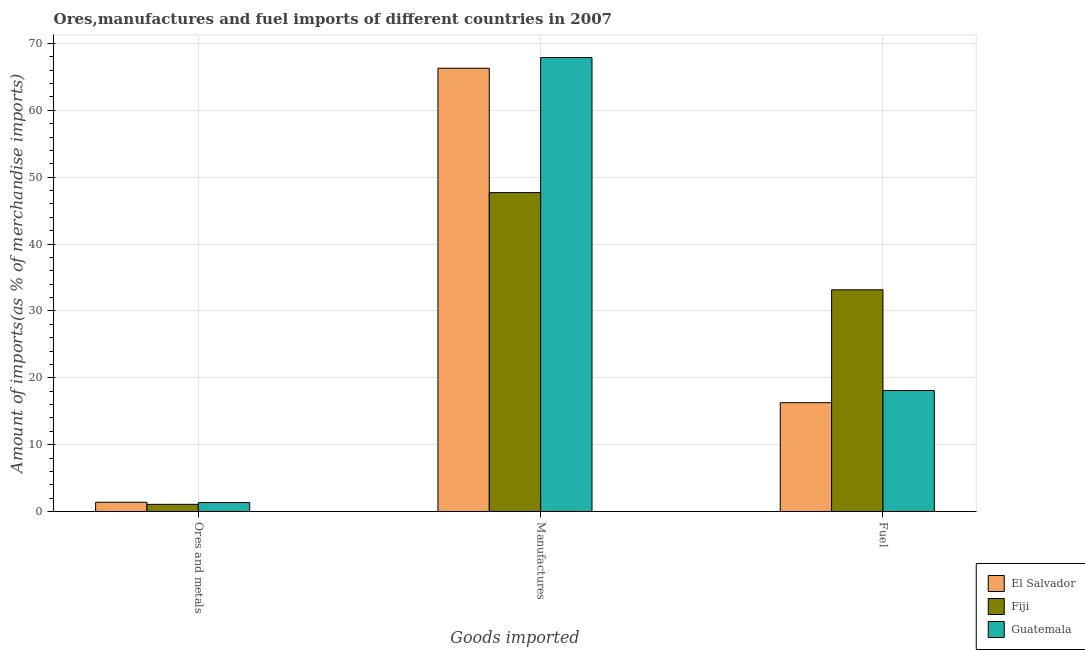How many different coloured bars are there?
Your answer should be very brief. 3. Are the number of bars per tick equal to the number of legend labels?
Your response must be concise. Yes. How many bars are there on the 1st tick from the right?
Ensure brevity in your answer.  3. What is the label of the 2nd group of bars from the left?
Keep it short and to the point. Manufactures. What is the percentage of ores and metals imports in El Salvador?
Give a very brief answer. 1.38. Across all countries, what is the maximum percentage of ores and metals imports?
Offer a very short reply. 1.38. Across all countries, what is the minimum percentage of fuel imports?
Provide a short and direct response. 16.27. In which country was the percentage of manufactures imports maximum?
Make the answer very short. Guatemala. In which country was the percentage of manufactures imports minimum?
Your response must be concise. Fiji. What is the total percentage of manufactures imports in the graph?
Your response must be concise. 181.9. What is the difference between the percentage of manufactures imports in Guatemala and that in Fiji?
Keep it short and to the point. 20.2. What is the difference between the percentage of manufactures imports in El Salvador and the percentage of ores and metals imports in Guatemala?
Provide a short and direct response. 64.96. What is the average percentage of manufactures imports per country?
Keep it short and to the point. 60.63. What is the difference between the percentage of ores and metals imports and percentage of manufactures imports in El Salvador?
Give a very brief answer. -64.92. In how many countries, is the percentage of ores and metals imports greater than 58 %?
Your answer should be compact. 0. What is the ratio of the percentage of fuel imports in Fiji to that in Guatemala?
Offer a terse response. 1.83. What is the difference between the highest and the second highest percentage of fuel imports?
Your answer should be compact. 15.07. What is the difference between the highest and the lowest percentage of fuel imports?
Your answer should be very brief. 16.89. Is the sum of the percentage of fuel imports in Fiji and El Salvador greater than the maximum percentage of ores and metals imports across all countries?
Give a very brief answer. Yes. What does the 2nd bar from the left in Fuel represents?
Give a very brief answer. Fiji. What does the 2nd bar from the right in Ores and metals represents?
Provide a short and direct response. Fiji. How many bars are there?
Your answer should be very brief. 9. Are all the bars in the graph horizontal?
Your response must be concise. No. What is the difference between two consecutive major ticks on the Y-axis?
Provide a succinct answer. 10. Does the graph contain grids?
Keep it short and to the point. Yes. Where does the legend appear in the graph?
Your response must be concise. Bottom right. How many legend labels are there?
Offer a very short reply. 3. What is the title of the graph?
Keep it short and to the point. Ores,manufactures and fuel imports of different countries in 2007. Does "Macao" appear as one of the legend labels in the graph?
Give a very brief answer. No. What is the label or title of the X-axis?
Provide a short and direct response. Goods imported. What is the label or title of the Y-axis?
Ensure brevity in your answer.  Amount of imports(as % of merchandise imports). What is the Amount of imports(as % of merchandise imports) of El Salvador in Ores and metals?
Ensure brevity in your answer.  1.38. What is the Amount of imports(as % of merchandise imports) in Fiji in Ores and metals?
Make the answer very short. 1.07. What is the Amount of imports(as % of merchandise imports) of Guatemala in Ores and metals?
Provide a succinct answer. 1.34. What is the Amount of imports(as % of merchandise imports) of El Salvador in Manufactures?
Give a very brief answer. 66.3. What is the Amount of imports(as % of merchandise imports) in Fiji in Manufactures?
Provide a short and direct response. 47.7. What is the Amount of imports(as % of merchandise imports) of Guatemala in Manufactures?
Your answer should be very brief. 67.9. What is the Amount of imports(as % of merchandise imports) of El Salvador in Fuel?
Your answer should be compact. 16.27. What is the Amount of imports(as % of merchandise imports) of Fiji in Fuel?
Your response must be concise. 33.16. What is the Amount of imports(as % of merchandise imports) of Guatemala in Fuel?
Your answer should be very brief. 18.09. Across all Goods imported, what is the maximum Amount of imports(as % of merchandise imports) of El Salvador?
Your answer should be compact. 66.3. Across all Goods imported, what is the maximum Amount of imports(as % of merchandise imports) in Fiji?
Provide a succinct answer. 47.7. Across all Goods imported, what is the maximum Amount of imports(as % of merchandise imports) of Guatemala?
Provide a short and direct response. 67.9. Across all Goods imported, what is the minimum Amount of imports(as % of merchandise imports) in El Salvador?
Provide a succinct answer. 1.38. Across all Goods imported, what is the minimum Amount of imports(as % of merchandise imports) of Fiji?
Give a very brief answer. 1.07. Across all Goods imported, what is the minimum Amount of imports(as % of merchandise imports) in Guatemala?
Your answer should be compact. 1.34. What is the total Amount of imports(as % of merchandise imports) in El Salvador in the graph?
Your answer should be compact. 83.95. What is the total Amount of imports(as % of merchandise imports) of Fiji in the graph?
Your answer should be very brief. 81.93. What is the total Amount of imports(as % of merchandise imports) in Guatemala in the graph?
Keep it short and to the point. 87.33. What is the difference between the Amount of imports(as % of merchandise imports) in El Salvador in Ores and metals and that in Manufactures?
Give a very brief answer. -64.92. What is the difference between the Amount of imports(as % of merchandise imports) of Fiji in Ores and metals and that in Manufactures?
Offer a very short reply. -46.63. What is the difference between the Amount of imports(as % of merchandise imports) of Guatemala in Ores and metals and that in Manufactures?
Provide a short and direct response. -66.56. What is the difference between the Amount of imports(as % of merchandise imports) in El Salvador in Ores and metals and that in Fuel?
Make the answer very short. -14.89. What is the difference between the Amount of imports(as % of merchandise imports) in Fiji in Ores and metals and that in Fuel?
Offer a terse response. -32.09. What is the difference between the Amount of imports(as % of merchandise imports) in Guatemala in Ores and metals and that in Fuel?
Give a very brief answer. -16.76. What is the difference between the Amount of imports(as % of merchandise imports) in El Salvador in Manufactures and that in Fuel?
Provide a succinct answer. 50.03. What is the difference between the Amount of imports(as % of merchandise imports) of Fiji in Manufactures and that in Fuel?
Provide a short and direct response. 14.54. What is the difference between the Amount of imports(as % of merchandise imports) in Guatemala in Manufactures and that in Fuel?
Provide a succinct answer. 49.8. What is the difference between the Amount of imports(as % of merchandise imports) of El Salvador in Ores and metals and the Amount of imports(as % of merchandise imports) of Fiji in Manufactures?
Provide a succinct answer. -46.32. What is the difference between the Amount of imports(as % of merchandise imports) of El Salvador in Ores and metals and the Amount of imports(as % of merchandise imports) of Guatemala in Manufactures?
Ensure brevity in your answer.  -66.52. What is the difference between the Amount of imports(as % of merchandise imports) of Fiji in Ores and metals and the Amount of imports(as % of merchandise imports) of Guatemala in Manufactures?
Offer a very short reply. -66.83. What is the difference between the Amount of imports(as % of merchandise imports) of El Salvador in Ores and metals and the Amount of imports(as % of merchandise imports) of Fiji in Fuel?
Your answer should be very brief. -31.78. What is the difference between the Amount of imports(as % of merchandise imports) in El Salvador in Ores and metals and the Amount of imports(as % of merchandise imports) in Guatemala in Fuel?
Keep it short and to the point. -16.71. What is the difference between the Amount of imports(as % of merchandise imports) in Fiji in Ores and metals and the Amount of imports(as % of merchandise imports) in Guatemala in Fuel?
Ensure brevity in your answer.  -17.03. What is the difference between the Amount of imports(as % of merchandise imports) in El Salvador in Manufactures and the Amount of imports(as % of merchandise imports) in Fiji in Fuel?
Your answer should be compact. 33.14. What is the difference between the Amount of imports(as % of merchandise imports) in El Salvador in Manufactures and the Amount of imports(as % of merchandise imports) in Guatemala in Fuel?
Give a very brief answer. 48.21. What is the difference between the Amount of imports(as % of merchandise imports) of Fiji in Manufactures and the Amount of imports(as % of merchandise imports) of Guatemala in Fuel?
Offer a terse response. 29.61. What is the average Amount of imports(as % of merchandise imports) in El Salvador per Goods imported?
Provide a short and direct response. 27.98. What is the average Amount of imports(as % of merchandise imports) of Fiji per Goods imported?
Your answer should be very brief. 27.31. What is the average Amount of imports(as % of merchandise imports) of Guatemala per Goods imported?
Offer a very short reply. 29.11. What is the difference between the Amount of imports(as % of merchandise imports) in El Salvador and Amount of imports(as % of merchandise imports) in Fiji in Ores and metals?
Provide a short and direct response. 0.31. What is the difference between the Amount of imports(as % of merchandise imports) in El Salvador and Amount of imports(as % of merchandise imports) in Guatemala in Ores and metals?
Your answer should be compact. 0.05. What is the difference between the Amount of imports(as % of merchandise imports) in Fiji and Amount of imports(as % of merchandise imports) in Guatemala in Ores and metals?
Make the answer very short. -0.27. What is the difference between the Amount of imports(as % of merchandise imports) in El Salvador and Amount of imports(as % of merchandise imports) in Fiji in Manufactures?
Give a very brief answer. 18.6. What is the difference between the Amount of imports(as % of merchandise imports) in El Salvador and Amount of imports(as % of merchandise imports) in Guatemala in Manufactures?
Offer a terse response. -1.6. What is the difference between the Amount of imports(as % of merchandise imports) of Fiji and Amount of imports(as % of merchandise imports) of Guatemala in Manufactures?
Offer a very short reply. -20.2. What is the difference between the Amount of imports(as % of merchandise imports) of El Salvador and Amount of imports(as % of merchandise imports) of Fiji in Fuel?
Offer a terse response. -16.89. What is the difference between the Amount of imports(as % of merchandise imports) of El Salvador and Amount of imports(as % of merchandise imports) of Guatemala in Fuel?
Your response must be concise. -1.82. What is the difference between the Amount of imports(as % of merchandise imports) in Fiji and Amount of imports(as % of merchandise imports) in Guatemala in Fuel?
Provide a short and direct response. 15.07. What is the ratio of the Amount of imports(as % of merchandise imports) of El Salvador in Ores and metals to that in Manufactures?
Offer a terse response. 0.02. What is the ratio of the Amount of imports(as % of merchandise imports) of Fiji in Ores and metals to that in Manufactures?
Offer a very short reply. 0.02. What is the ratio of the Amount of imports(as % of merchandise imports) of Guatemala in Ores and metals to that in Manufactures?
Give a very brief answer. 0.02. What is the ratio of the Amount of imports(as % of merchandise imports) in El Salvador in Ores and metals to that in Fuel?
Your answer should be compact. 0.09. What is the ratio of the Amount of imports(as % of merchandise imports) of Fiji in Ores and metals to that in Fuel?
Your answer should be compact. 0.03. What is the ratio of the Amount of imports(as % of merchandise imports) in Guatemala in Ores and metals to that in Fuel?
Keep it short and to the point. 0.07. What is the ratio of the Amount of imports(as % of merchandise imports) in El Salvador in Manufactures to that in Fuel?
Provide a short and direct response. 4.07. What is the ratio of the Amount of imports(as % of merchandise imports) of Fiji in Manufactures to that in Fuel?
Offer a terse response. 1.44. What is the ratio of the Amount of imports(as % of merchandise imports) of Guatemala in Manufactures to that in Fuel?
Your answer should be very brief. 3.75. What is the difference between the highest and the second highest Amount of imports(as % of merchandise imports) of El Salvador?
Your answer should be compact. 50.03. What is the difference between the highest and the second highest Amount of imports(as % of merchandise imports) of Fiji?
Your answer should be very brief. 14.54. What is the difference between the highest and the second highest Amount of imports(as % of merchandise imports) of Guatemala?
Offer a terse response. 49.8. What is the difference between the highest and the lowest Amount of imports(as % of merchandise imports) of El Salvador?
Make the answer very short. 64.92. What is the difference between the highest and the lowest Amount of imports(as % of merchandise imports) of Fiji?
Offer a very short reply. 46.63. What is the difference between the highest and the lowest Amount of imports(as % of merchandise imports) of Guatemala?
Offer a very short reply. 66.56. 